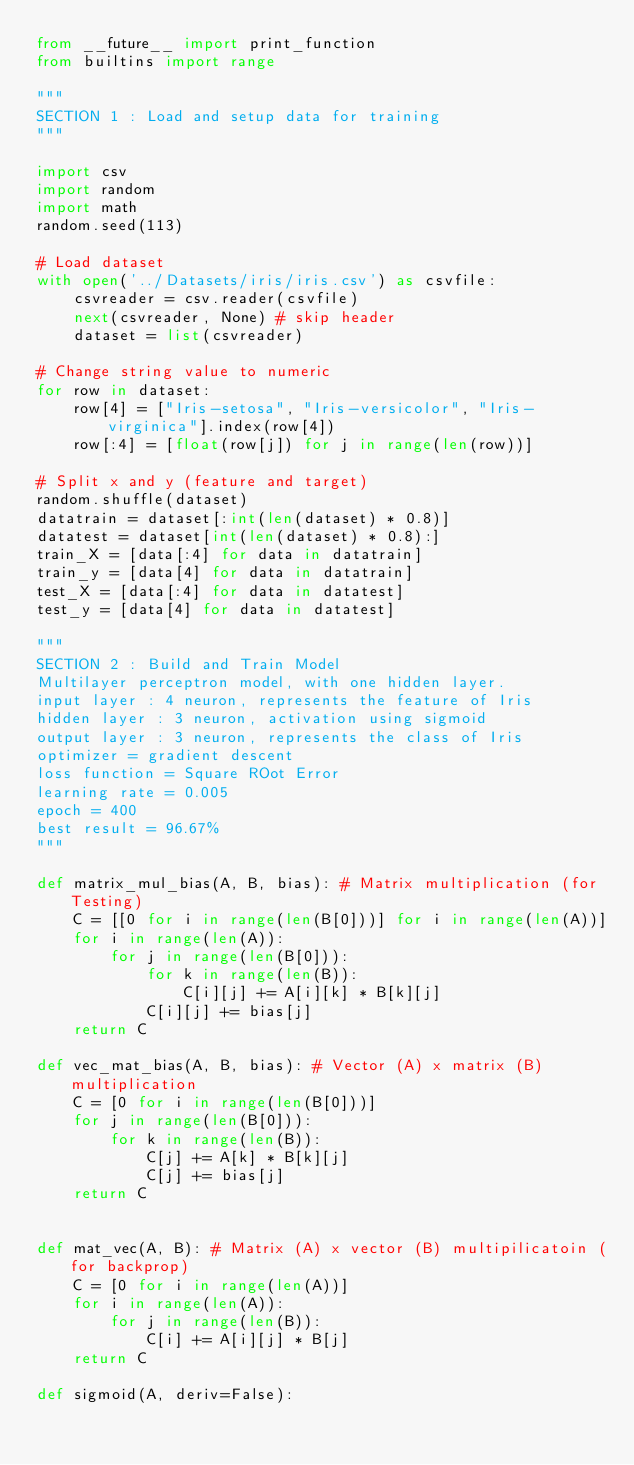Convert code to text. <code><loc_0><loc_0><loc_500><loc_500><_Python_>from __future__ import print_function
from builtins import range

"""
SECTION 1 : Load and setup data for training
"""

import csv
import random
import math
random.seed(113)

# Load dataset
with open('../Datasets/iris/iris.csv') as csvfile:
    csvreader = csv.reader(csvfile)
    next(csvreader, None) # skip header
    dataset = list(csvreader)

# Change string value to numeric
for row in dataset:
    row[4] = ["Iris-setosa", "Iris-versicolor", "Iris-virginica"].index(row[4])
    row[:4] = [float(row[j]) for j in range(len(row))]

# Split x and y (feature and target)
random.shuffle(dataset)
datatrain = dataset[:int(len(dataset) * 0.8)]
datatest = dataset[int(len(dataset) * 0.8):]
train_X = [data[:4] for data in datatrain]
train_y = [data[4] for data in datatrain]
test_X = [data[:4] for data in datatest]
test_y = [data[4] for data in datatest]

"""
SECTION 2 : Build and Train Model
Multilayer perceptron model, with one hidden layer.
input layer : 4 neuron, represents the feature of Iris
hidden layer : 3 neuron, activation using sigmoid
output layer : 3 neuron, represents the class of Iris
optimizer = gradient descent
loss function = Square ROot Error
learning rate = 0.005
epoch = 400
best result = 96.67%
"""

def matrix_mul_bias(A, B, bias): # Matrix multiplication (for Testing)
    C = [[0 for i in range(len(B[0]))] for i in range(len(A))]    
    for i in range(len(A)):
        for j in range(len(B[0])):
            for k in range(len(B)):
                C[i][j] += A[i][k] * B[k][j]
            C[i][j] += bias[j]
    return C

def vec_mat_bias(A, B, bias): # Vector (A) x matrix (B) multiplication
    C = [0 for i in range(len(B[0]))]
    for j in range(len(B[0])):
        for k in range(len(B)):
            C[j] += A[k] * B[k][j]
            C[j] += bias[j]
    return C


def mat_vec(A, B): # Matrix (A) x vector (B) multipilicatoin (for backprop)
    C = [0 for i in range(len(A))]
    for i in range(len(A)):
        for j in range(len(B)):
            C[i] += A[i][j] * B[j]
    return C

def sigmoid(A, deriv=False):</code> 